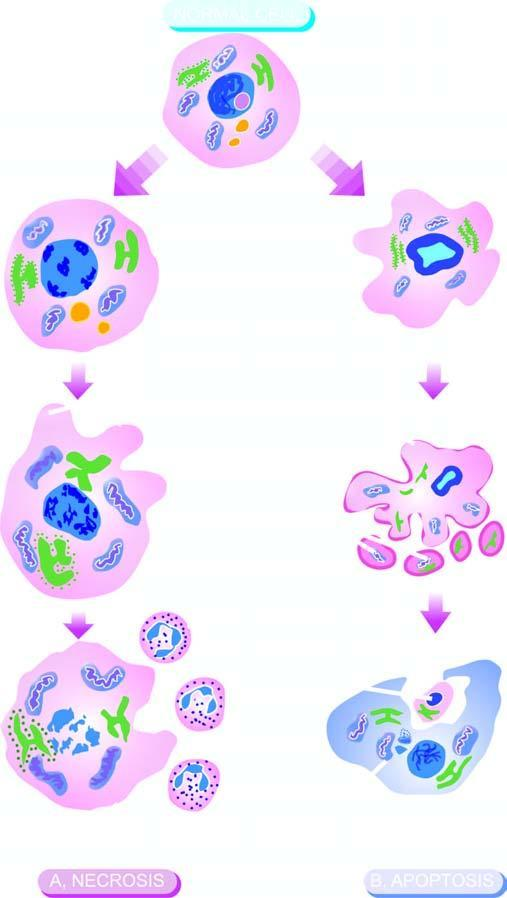s cell necrosis identified by homogeneous, eosinophilic cytoplasm?
Answer the question using a single word or phrase. Yes 